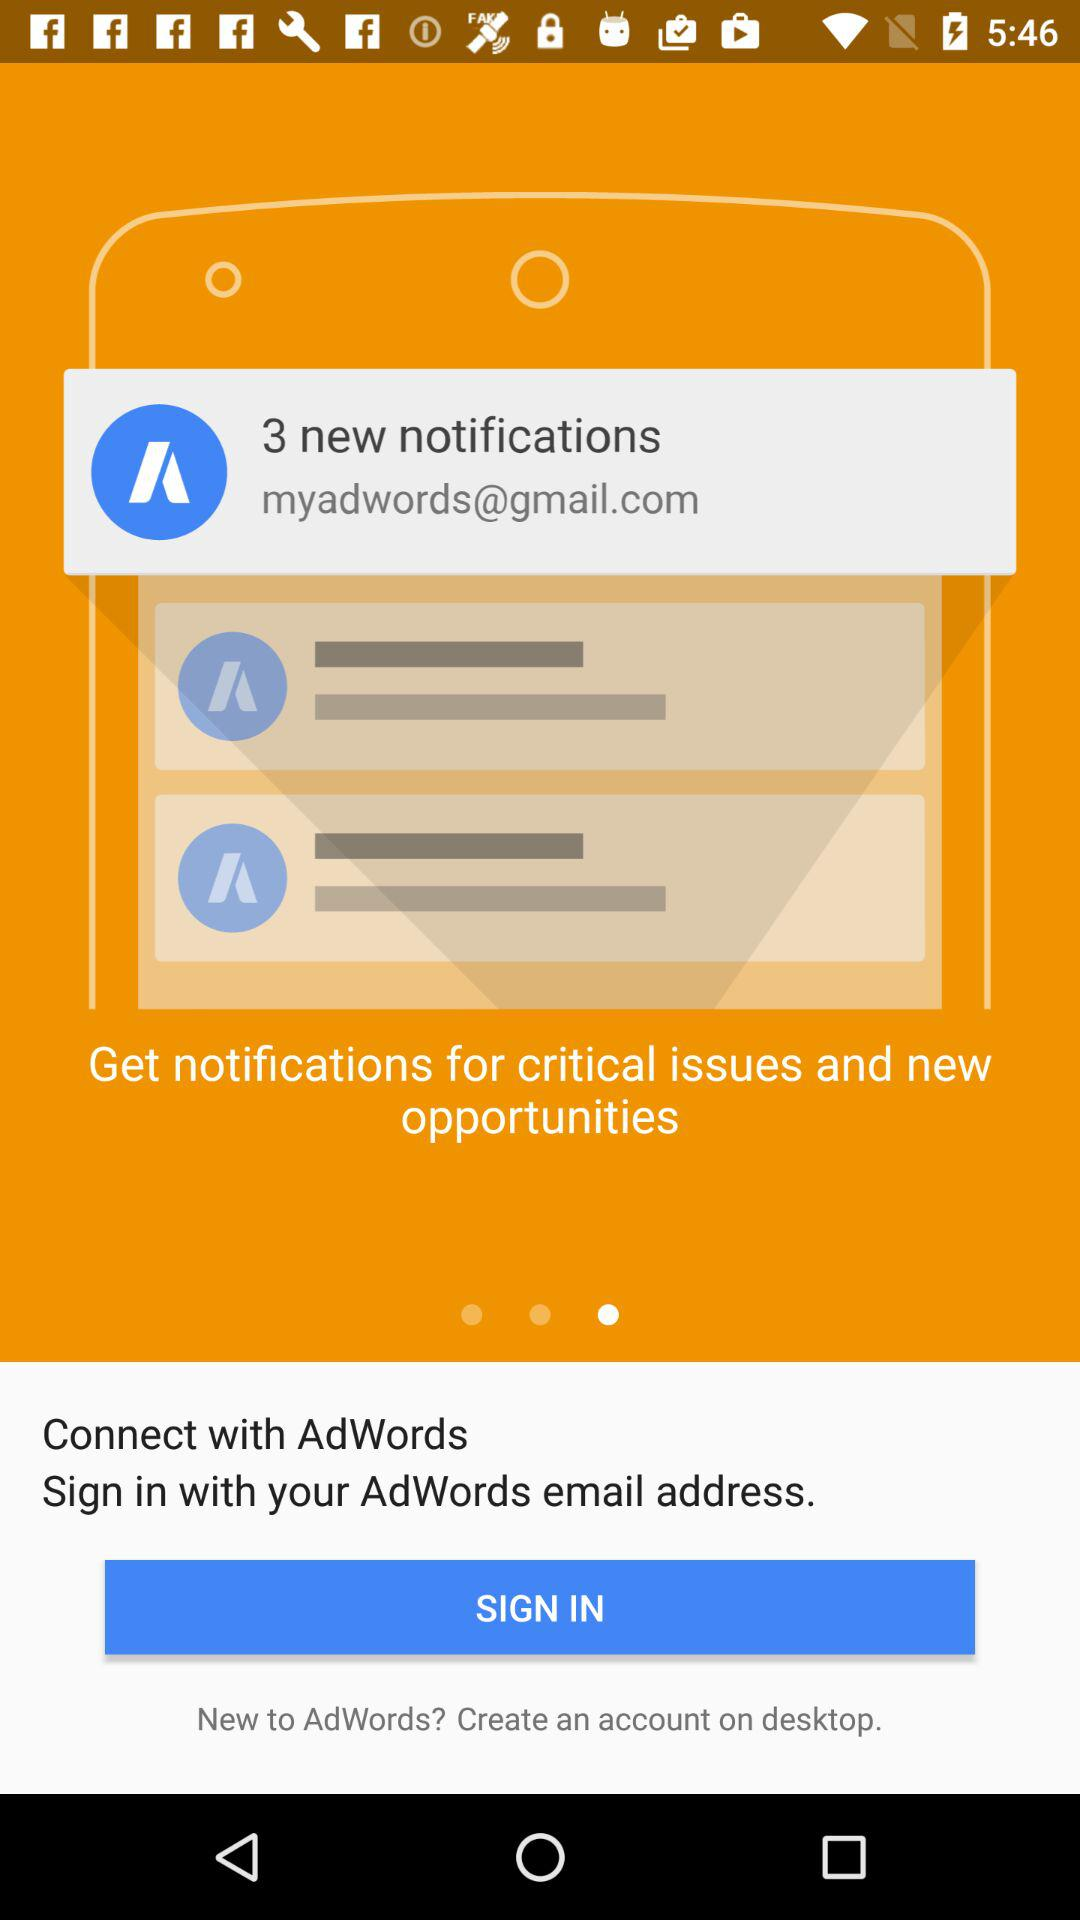What is the email address of the user? The email address of the user is myadwords@gmail.com. 